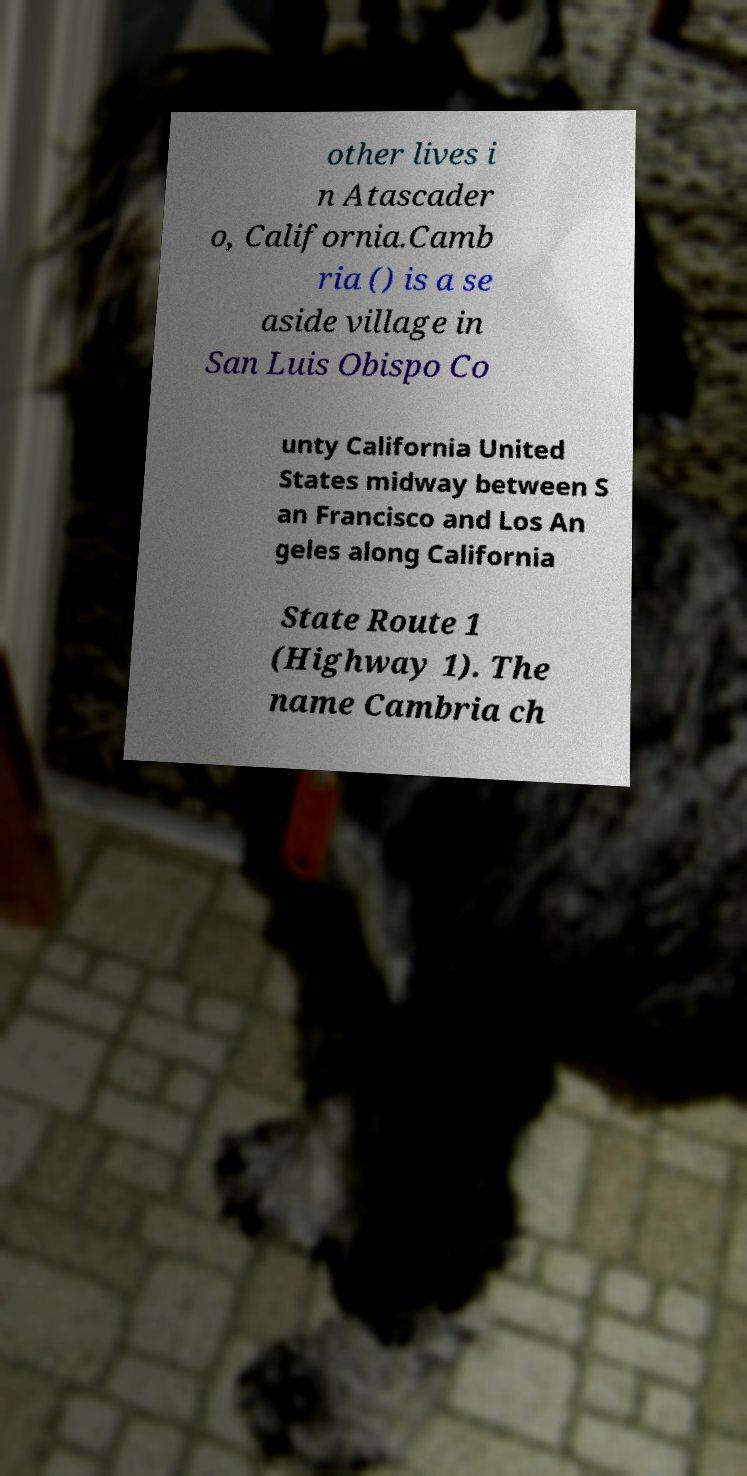Can you accurately transcribe the text from the provided image for me? other lives i n Atascader o, California.Camb ria () is a se aside village in San Luis Obispo Co unty California United States midway between S an Francisco and Los An geles along California State Route 1 (Highway 1). The name Cambria ch 